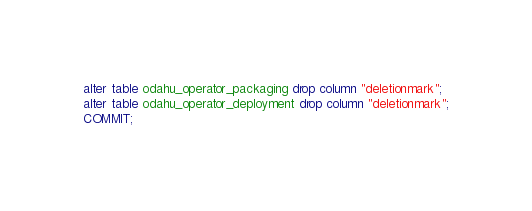Convert code to text. <code><loc_0><loc_0><loc_500><loc_500><_SQL_>alter table odahu_operator_packaging drop column "deletionmark";
alter table odahu_operator_deployment drop column "deletionmark";
COMMIT;</code> 